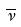<formula> <loc_0><loc_0><loc_500><loc_500>\overline { \nu }</formula> 